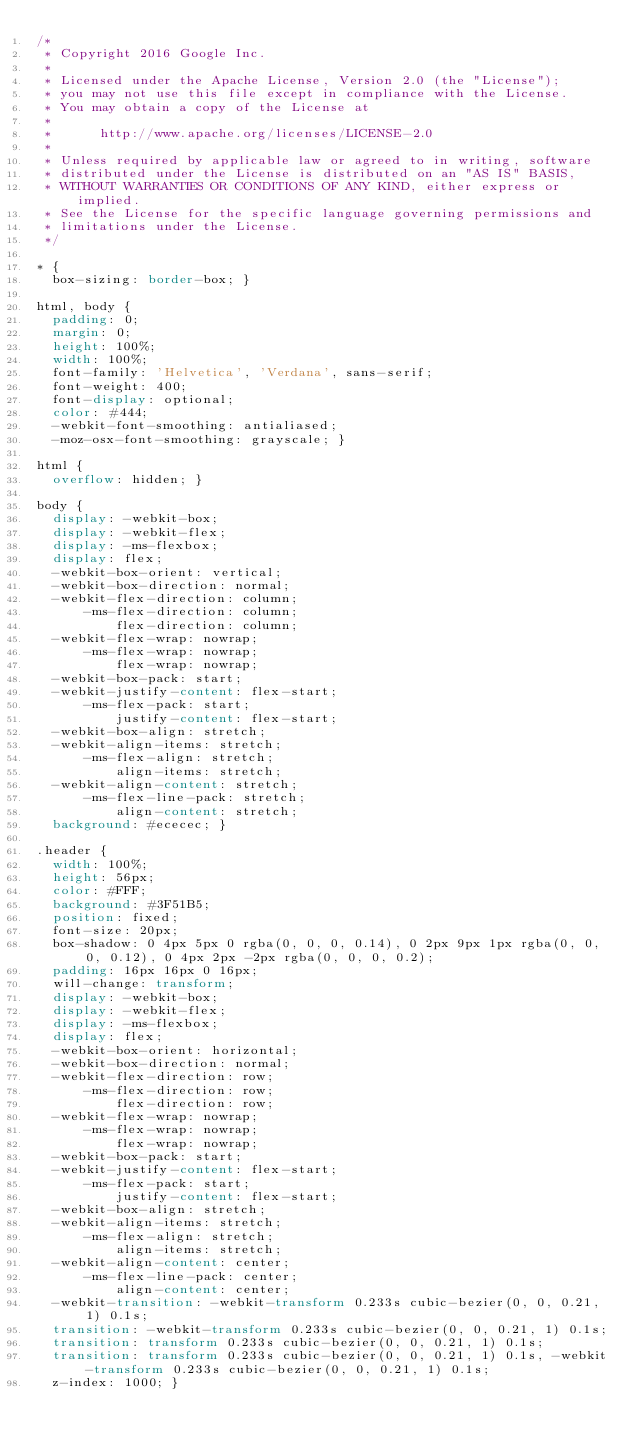Convert code to text. <code><loc_0><loc_0><loc_500><loc_500><_CSS_>/*
 * Copyright 2016 Google Inc.
 *
 * Licensed under the Apache License, Version 2.0 (the "License");
 * you may not use this file except in compliance with the License.
 * You may obtain a copy of the License at
 *
 *      http://www.apache.org/licenses/LICENSE-2.0
 *
 * Unless required by applicable law or agreed to in writing, software
 * distributed under the License is distributed on an "AS IS" BASIS,
 * WITHOUT WARRANTIES OR CONDITIONS OF ANY KIND, either express or implied.
 * See the License for the specific language governing permissions and
 * limitations under the License.
 */

* {
  box-sizing: border-box; }

html, body {
  padding: 0;
  margin: 0;
  height: 100%;
  width: 100%;
  font-family: 'Helvetica', 'Verdana', sans-serif;
  font-weight: 400;
  font-display: optional;
  color: #444;
  -webkit-font-smoothing: antialiased;
  -moz-osx-font-smoothing: grayscale; }

html {
  overflow: hidden; }

body {
  display: -webkit-box;
  display: -webkit-flex;
  display: -ms-flexbox;
  display: flex;
  -webkit-box-orient: vertical;
  -webkit-box-direction: normal;
  -webkit-flex-direction: column;
      -ms-flex-direction: column;
          flex-direction: column;
  -webkit-flex-wrap: nowrap;
      -ms-flex-wrap: nowrap;
          flex-wrap: nowrap;
  -webkit-box-pack: start;
  -webkit-justify-content: flex-start;
      -ms-flex-pack: start;
          justify-content: flex-start;
  -webkit-box-align: stretch;
  -webkit-align-items: stretch;
      -ms-flex-align: stretch;
          align-items: stretch;
  -webkit-align-content: stretch;
      -ms-flex-line-pack: stretch;
          align-content: stretch;
  background: #ececec; }

.header {
  width: 100%;
  height: 56px;
  color: #FFF;
  background: #3F51B5;
  position: fixed;
  font-size: 20px;
  box-shadow: 0 4px 5px 0 rgba(0, 0, 0, 0.14), 0 2px 9px 1px rgba(0, 0, 0, 0.12), 0 4px 2px -2px rgba(0, 0, 0, 0.2);
  padding: 16px 16px 0 16px;
  will-change: transform;
  display: -webkit-box;
  display: -webkit-flex;
  display: -ms-flexbox;
  display: flex;
  -webkit-box-orient: horizontal;
  -webkit-box-direction: normal;
  -webkit-flex-direction: row;
      -ms-flex-direction: row;
          flex-direction: row;
  -webkit-flex-wrap: nowrap;
      -ms-flex-wrap: nowrap;
          flex-wrap: nowrap;
  -webkit-box-pack: start;
  -webkit-justify-content: flex-start;
      -ms-flex-pack: start;
          justify-content: flex-start;
  -webkit-box-align: stretch;
  -webkit-align-items: stretch;
      -ms-flex-align: stretch;
          align-items: stretch;
  -webkit-align-content: center;
      -ms-flex-line-pack: center;
          align-content: center;
  -webkit-transition: -webkit-transform 0.233s cubic-bezier(0, 0, 0.21, 1) 0.1s;
  transition: -webkit-transform 0.233s cubic-bezier(0, 0, 0.21, 1) 0.1s;
  transition: transform 0.233s cubic-bezier(0, 0, 0.21, 1) 0.1s;
  transition: transform 0.233s cubic-bezier(0, 0, 0.21, 1) 0.1s, -webkit-transform 0.233s cubic-bezier(0, 0, 0.21, 1) 0.1s;
  z-index: 1000; }</code> 